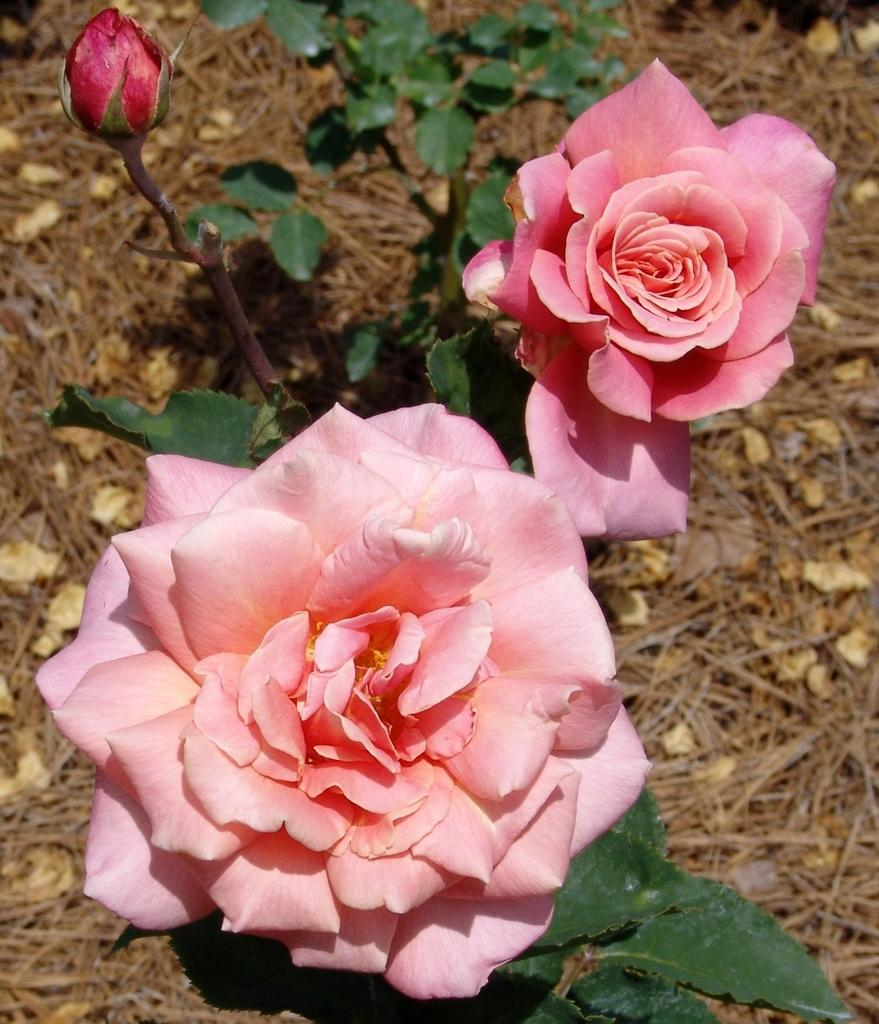How many rose flowers are in the image? There are two rose flowers in the image. What else can be seen in the image besides the rose flowers? There are leaves and grass at the bottom of the image. Are there any leaves visible in the image? Yes, there are leaves in the image. What type of toy can be seen in the box in the image? There is no toy or box present in the image; it features two rose flowers, leaves, and grass. What role does the society play in the image? There is no reference to society in the image; it focuses on natural elements such as flowers, leaves, and grass. 